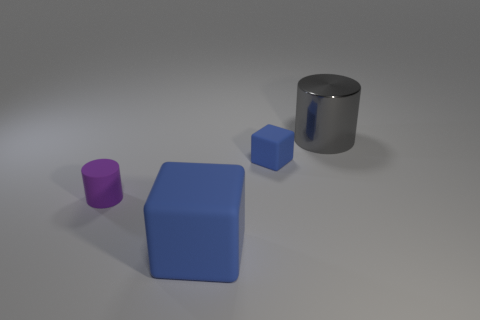There is a large matte object that is the same color as the small rubber cube; what shape is it?
Offer a very short reply. Cube. Is there any other thing of the same color as the metal thing?
Ensure brevity in your answer.  No. There is a tiny cube that is on the right side of the blue object that is in front of the small matte cube; are there any matte objects that are left of it?
Give a very brief answer. Yes. There is a cylinder in front of the gray cylinder; is its color the same as the cylinder on the right side of the large blue rubber object?
Your answer should be very brief. No. There is a blue object that is behind the rubber object in front of the cylinder left of the large gray cylinder; what is its size?
Provide a short and direct response. Small. What number of other objects are the same material as the small block?
Provide a short and direct response. 2. What is the size of the cylinder that is in front of the tiny blue block?
Your answer should be very brief. Small. What number of objects are both left of the large cylinder and behind the purple cylinder?
Provide a short and direct response. 1. What is the cylinder on the right side of the rubber object in front of the matte cylinder made of?
Ensure brevity in your answer.  Metal. What is the material of the tiny purple object that is the same shape as the large gray thing?
Keep it short and to the point. Rubber. 